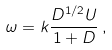<formula> <loc_0><loc_0><loc_500><loc_500>\omega = k \frac { D ^ { 1 / 2 } U } { 1 + D } \, ,</formula> 